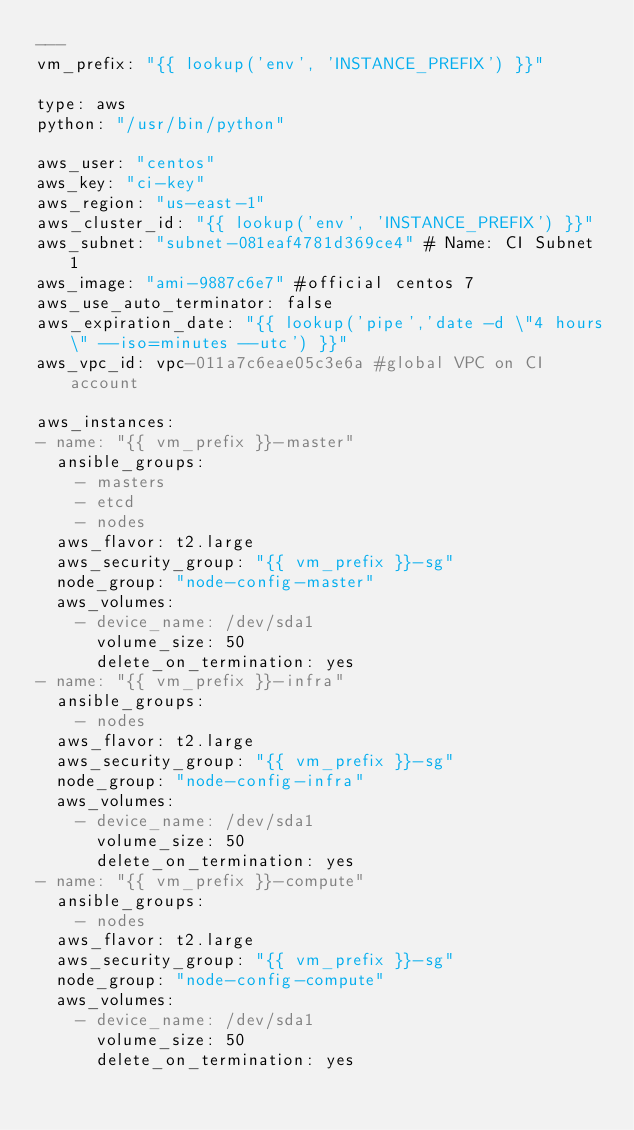<code> <loc_0><loc_0><loc_500><loc_500><_YAML_>---
vm_prefix: "{{ lookup('env', 'INSTANCE_PREFIX') }}"

type: aws
python: "/usr/bin/python"

aws_user: "centos"
aws_key: "ci-key"
aws_region: "us-east-1"
aws_cluster_id: "{{ lookup('env', 'INSTANCE_PREFIX') }}"
aws_subnet: "subnet-081eaf4781d369ce4" # Name: CI Subnet 1
aws_image: "ami-9887c6e7" #official centos 7
aws_use_auto_terminator: false
aws_expiration_date: "{{ lookup('pipe','date -d \"4 hours\" --iso=minutes --utc') }}"
aws_vpc_id: vpc-011a7c6eae05c3e6a #global VPC on CI account

aws_instances:
- name: "{{ vm_prefix }}-master"
  ansible_groups:
    - masters
    - etcd
    - nodes
  aws_flavor: t2.large
  aws_security_group: "{{ vm_prefix }}-sg"
  node_group: "node-config-master"
  aws_volumes:
    - device_name: /dev/sda1
      volume_size: 50
      delete_on_termination: yes
- name: "{{ vm_prefix }}-infra"
  ansible_groups:
    - nodes
  aws_flavor: t2.large
  aws_security_group: "{{ vm_prefix }}-sg"
  node_group: "node-config-infra"
  aws_volumes:
    - device_name: /dev/sda1
      volume_size: 50
      delete_on_termination: yes
- name: "{{ vm_prefix }}-compute"
  ansible_groups:
    - nodes
  aws_flavor: t2.large
  aws_security_group: "{{ vm_prefix }}-sg"
  node_group: "node-config-compute"
  aws_volumes:
    - device_name: /dev/sda1
      volume_size: 50
      delete_on_termination: yes
</code> 